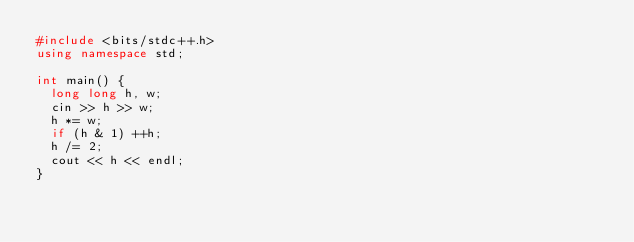<code> <loc_0><loc_0><loc_500><loc_500><_C++_>#include <bits/stdc++.h>
using namespace std;

int main() {
  long long h, w;
  cin >> h >> w;
  h *= w;
  if (h & 1) ++h;
  h /= 2;
  cout << h << endl;
}</code> 